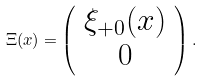<formula> <loc_0><loc_0><loc_500><loc_500>\Xi ( x ) = \left ( \begin{array} { c } \xi _ { + 0 } ( x ) \\ 0 \end{array} \right ) .</formula> 